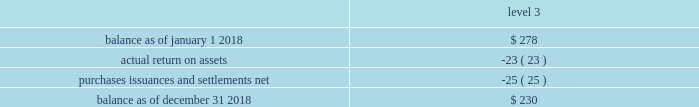Asset category target allocation total quoted prices in active markets for identical assets ( level 1 ) significant observable inputs ( level 2 ) significant unobservable inputs .
Balance as of january 1 , 2017 .
$ 140 actual return on assets .
2 purchases , issuances and settlements , net .
136 balance as of december 31 , 2017 .
$ 278 the company 2019s postretirement benefit plans have different levels of funded status and the assets are held under various trusts .
The investments and risk mitigation strategies for the plans are tailored specifically for each trust .
In setting new strategic asset mixes , consideration is given to the likelihood that the selected asset allocation will effectively fund the projected plan liabilities and meet the risk tolerance criteria of the company .
The company periodically updates the long-term , strategic asset allocations for these plans through asset liability studies and uses various analytics to determine the optimal asset allocation .
Considerations include plan liability characteristics , liquidity needs , funding requirements , expected rates of return and the distribution of returns .
In 2012 , the company implemented a de-risking strategy for the american water pension plan after conducting an asset-liability study to reduce the volatility of the funded status of the plan .
As part of the de-risking strategy , the company revised the asset allocations to increase the matching characteristics of fixed- income assets relative to liabilities .
The fixed income portion of the portfolio was designed to match the bond- .
By what percentage level 3 balance decrease during 2018? 
Computations: ((230 - 278) / 278)
Answer: -0.17266. 